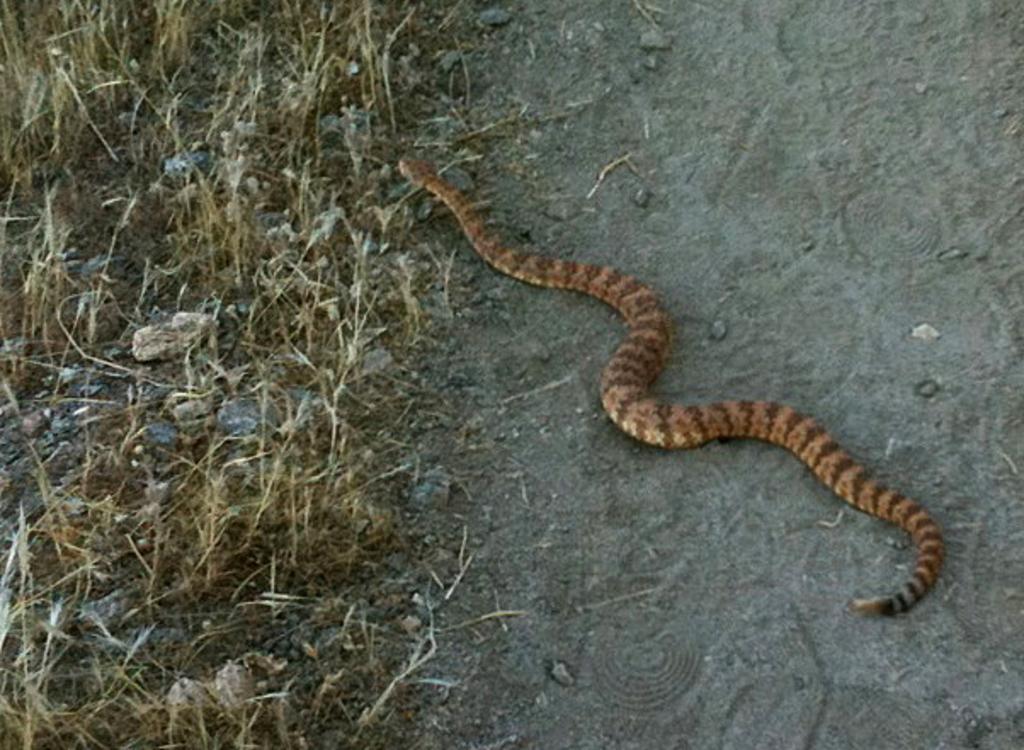Could you give a brief overview of what you see in this image? In the center of the image, we can see a snake on the ground and there are plants and stones. 